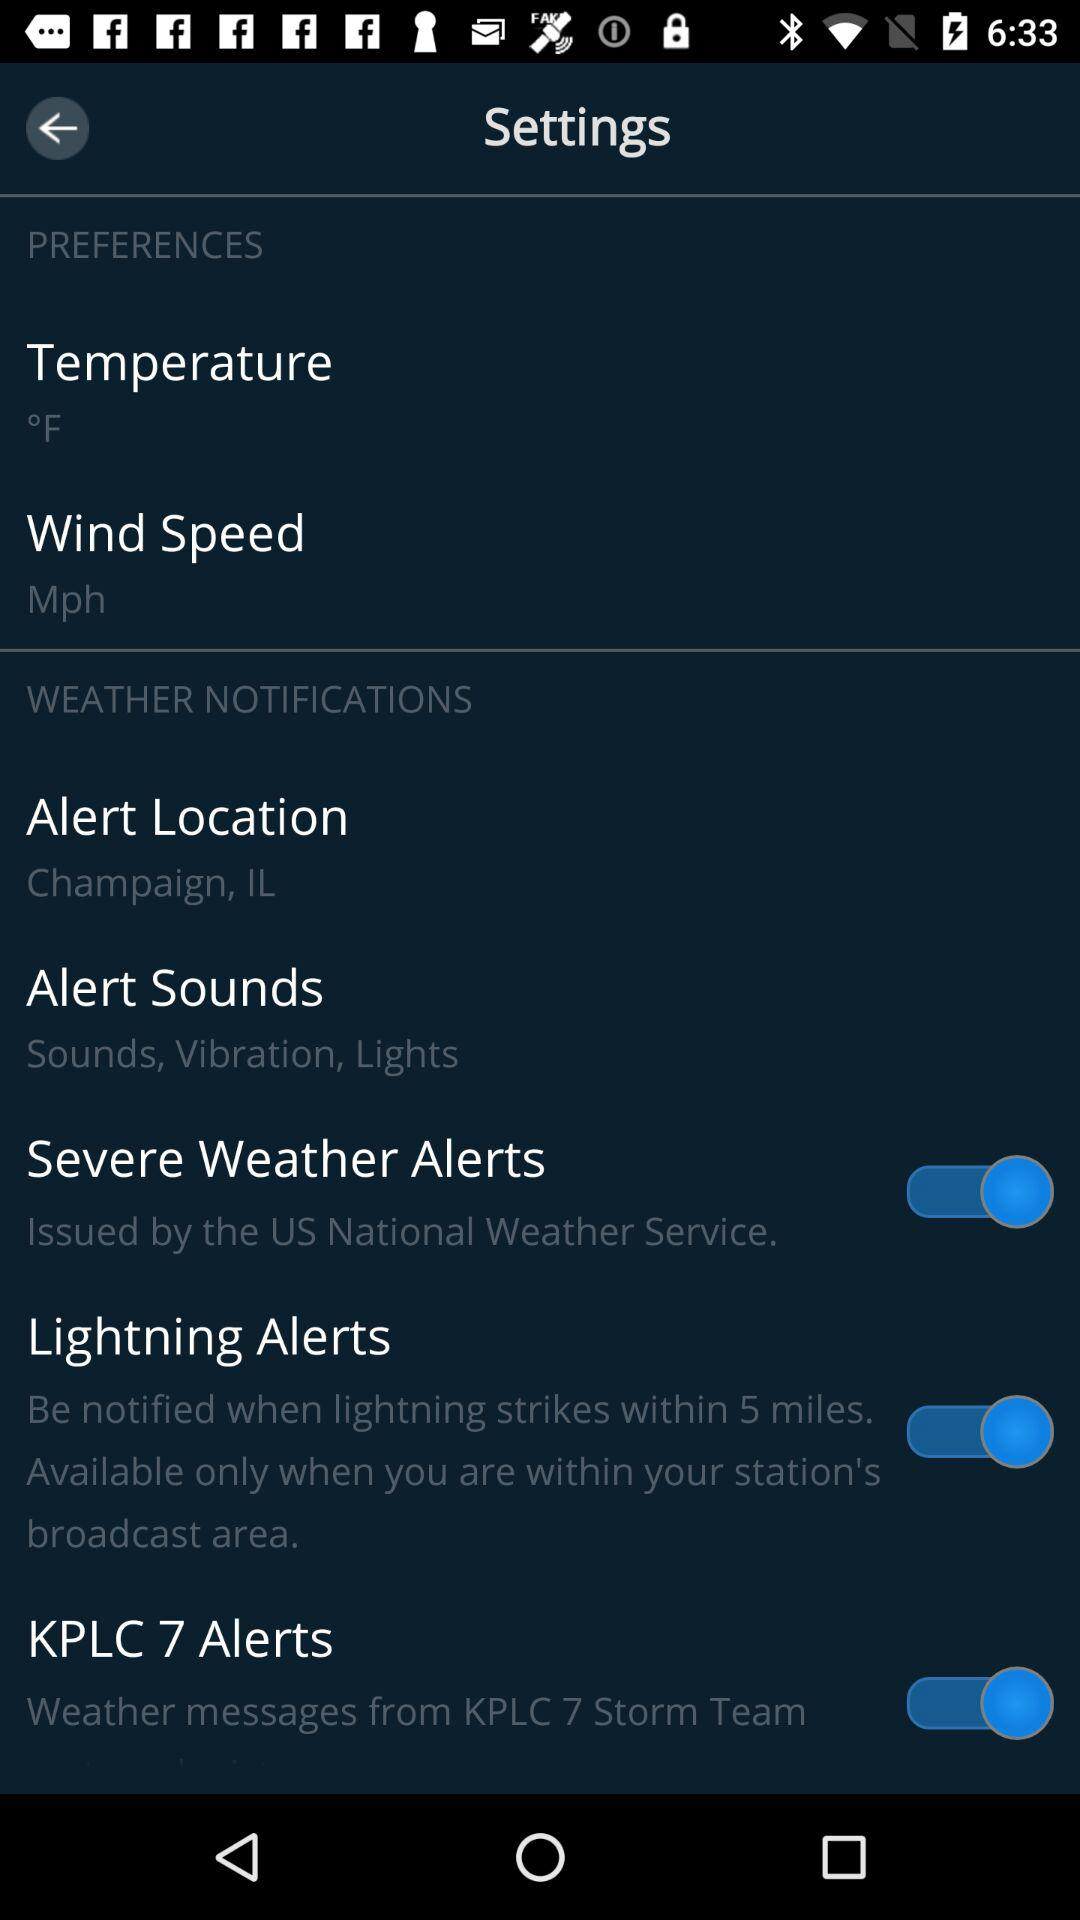What is the current state of "Lightning Alerts"? The current state of "Lightning Alerts" is "on". 